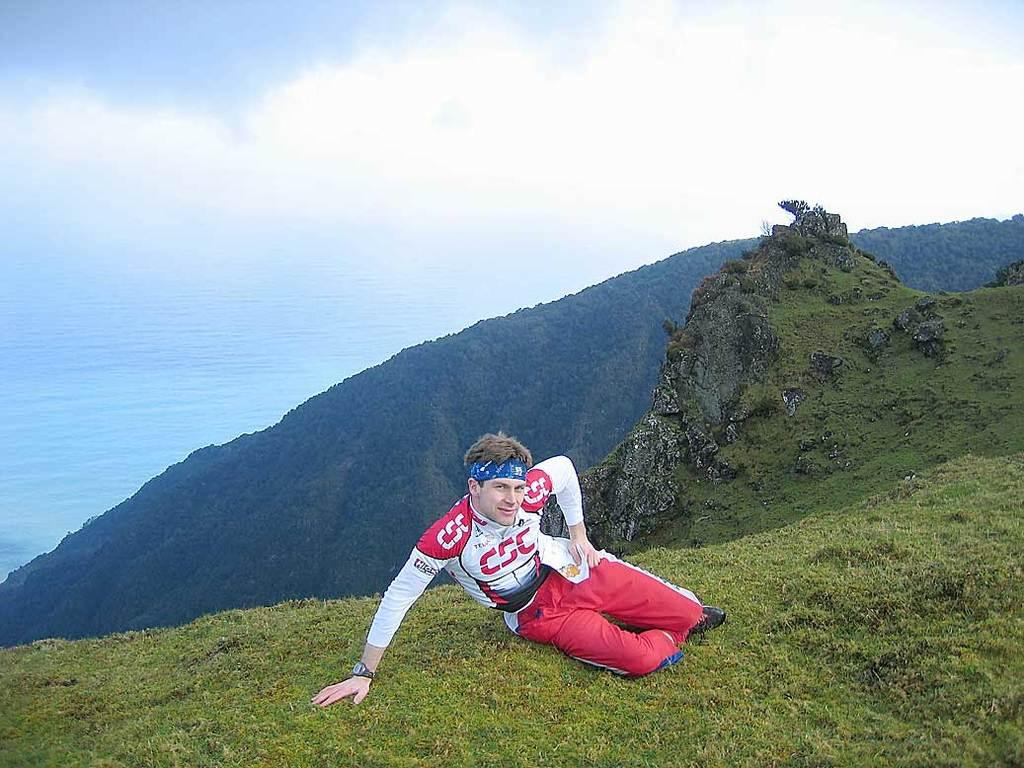Who is present in the image? There is a man in the image. What is the man wearing? The man is wearing clothes. Where is the man sitting? The man is sitting in the grass. What can be seen in the background of the image? The sky is visible in the image. How many grapes are the man's brothers eating in the image? There is no mention of grapes or the man's brothers in the image, so we cannot determine how many grapes they might be eating. 